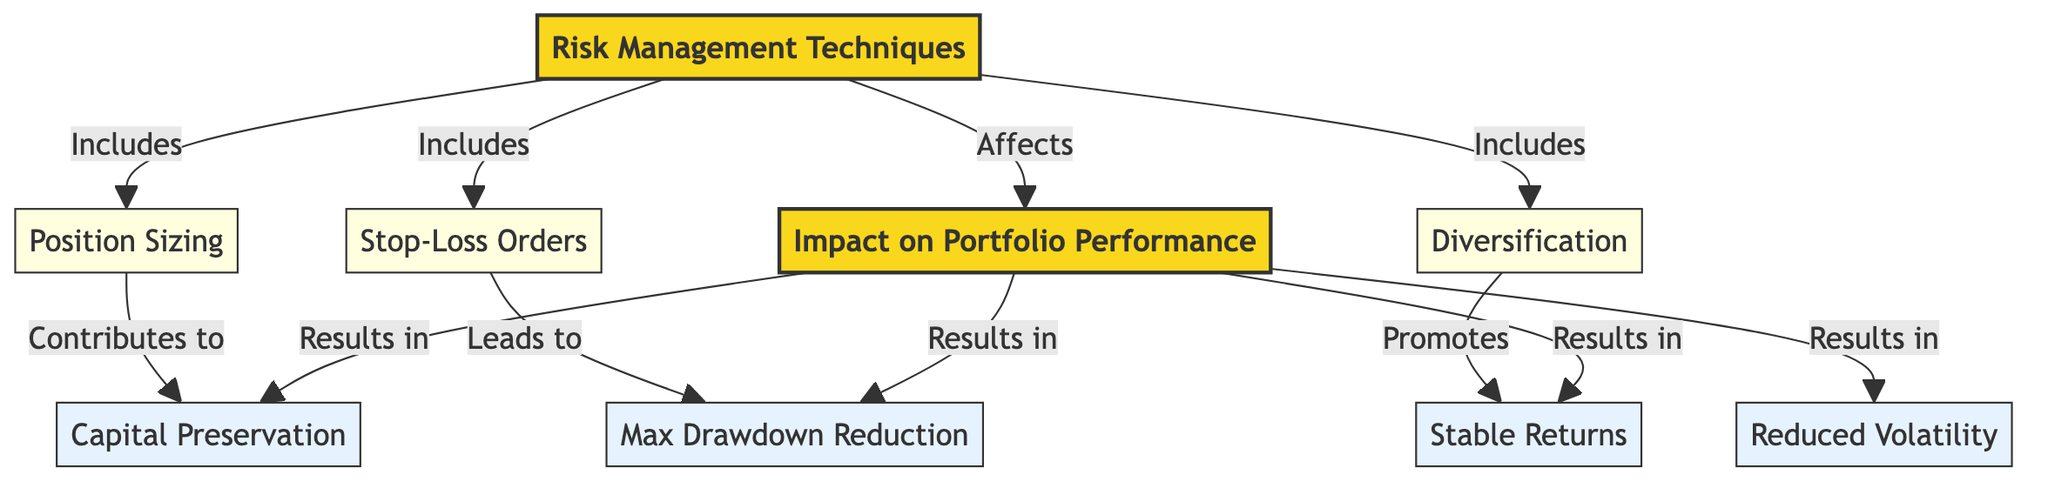What are the three primary risk management techniques listed in the diagram? The diagram lists three techniques: Position Sizing, Stop-Loss Orders, and Diversification. Each technique is connected to the main node labeled "Risk Management Techniques," indicating that they are part of the broader category of techniques used for managing risk.
Answer: Position Sizing, Stop-Loss Orders, Diversification How many impact nodes are there in relation to portfolio performance? The diagram connects four impact nodes to the Performance node: Capital Preservation, Max Drawdown Reduction, Stable Returns, and Reduced Volatility. This establishes the specific impacts that risk management techniques have on overall portfolio performance.
Answer: Four Which risk management technique contributes to capital preservation? The diagram indicates that Position Sizing contributes to Capital Preservation, as it is directly linked to this impact node. This shows the significance of how managing the size of positions can help protect capital.
Answer: Position Sizing What is the relationship between Stop-Loss Orders and Max Drawdown Reduction? The diagram shows that Stop-Loss Orders lead to Max Drawdown Reduction, indicating a direct impact of implementing stop-loss orders on reducing the maximum potential loss in a trading strategy.
Answer: Leads to Which impact node results from the entire set of risk management techniques? The diagram illustrates that Capital Preservation is a key result of the risk management techniques as a whole, showcasing that the application of various techniques leads to the preservation of capital in trading.
Answer: Capital Preservation How many techniques specifically promote stable returns? The diagram indicates that Diversification promotes stable returns. Since Diversification is the only technique connected to this impact node, it suggests that its effectiveness is vital in achieving stability in returns.
Answer: One 